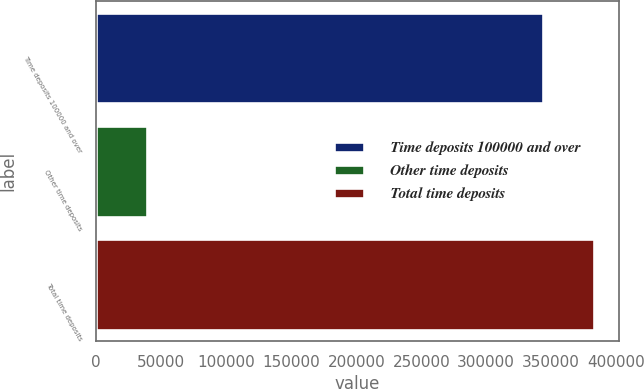Convert chart. <chart><loc_0><loc_0><loc_500><loc_500><bar_chart><fcel>Time deposits 100000 and over<fcel>Other time deposits<fcel>Total time deposits<nl><fcel>343533<fcel>39297<fcel>382830<nl></chart> 